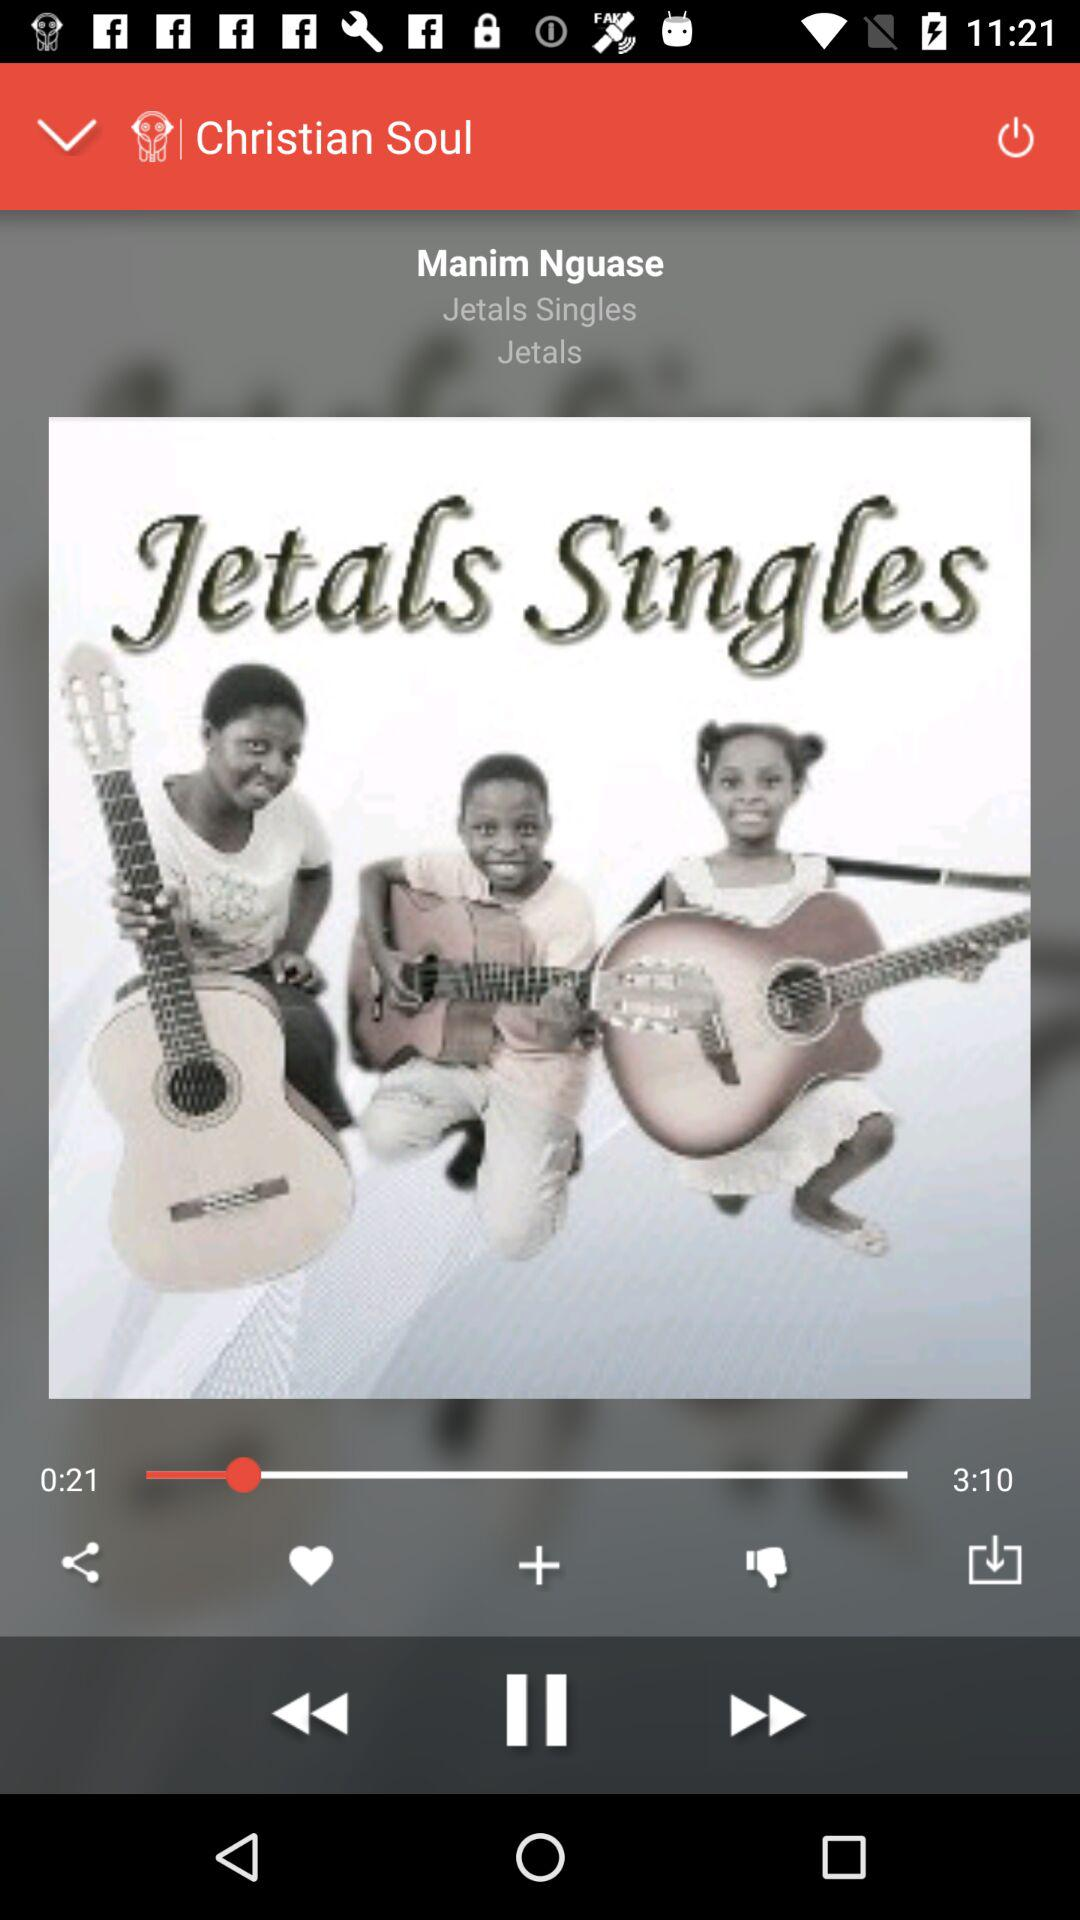What song has been played? The song that has been played is "Jetals Singles". 